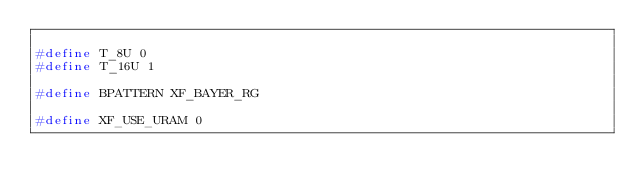Convert code to text. <code><loc_0><loc_0><loc_500><loc_500><_C_>
#define T_8U 0
#define T_16U 1

#define BPATTERN XF_BAYER_RG

#define XF_USE_URAM 0
</code> 